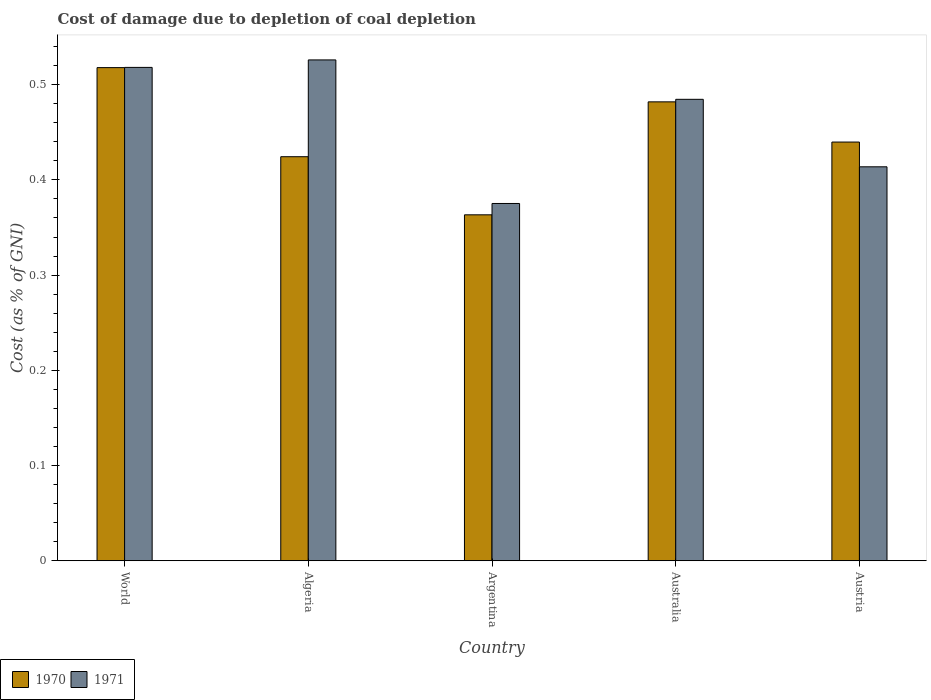How many groups of bars are there?
Ensure brevity in your answer.  5. Are the number of bars on each tick of the X-axis equal?
Provide a short and direct response. Yes. How many bars are there on the 4th tick from the right?
Provide a succinct answer. 2. What is the label of the 5th group of bars from the left?
Keep it short and to the point. Austria. What is the cost of damage caused due to coal depletion in 1971 in Australia?
Provide a short and direct response. 0.48. Across all countries, what is the maximum cost of damage caused due to coal depletion in 1971?
Give a very brief answer. 0.53. Across all countries, what is the minimum cost of damage caused due to coal depletion in 1971?
Offer a very short reply. 0.38. What is the total cost of damage caused due to coal depletion in 1970 in the graph?
Make the answer very short. 2.23. What is the difference between the cost of damage caused due to coal depletion in 1970 in Argentina and that in Australia?
Your response must be concise. -0.12. What is the difference between the cost of damage caused due to coal depletion in 1970 in Argentina and the cost of damage caused due to coal depletion in 1971 in World?
Ensure brevity in your answer.  -0.15. What is the average cost of damage caused due to coal depletion in 1970 per country?
Your answer should be very brief. 0.45. What is the difference between the cost of damage caused due to coal depletion of/in 1970 and cost of damage caused due to coal depletion of/in 1971 in Algeria?
Provide a succinct answer. -0.1. In how many countries, is the cost of damage caused due to coal depletion in 1971 greater than 0.4 %?
Provide a short and direct response. 4. What is the ratio of the cost of damage caused due to coal depletion in 1970 in Argentina to that in Australia?
Your answer should be very brief. 0.75. Is the difference between the cost of damage caused due to coal depletion in 1970 in Algeria and World greater than the difference between the cost of damage caused due to coal depletion in 1971 in Algeria and World?
Offer a terse response. No. What is the difference between the highest and the second highest cost of damage caused due to coal depletion in 1971?
Provide a succinct answer. 0.01. What is the difference between the highest and the lowest cost of damage caused due to coal depletion in 1970?
Make the answer very short. 0.15. In how many countries, is the cost of damage caused due to coal depletion in 1970 greater than the average cost of damage caused due to coal depletion in 1970 taken over all countries?
Provide a short and direct response. 2. What does the 2nd bar from the right in Algeria represents?
Keep it short and to the point. 1970. How many bars are there?
Keep it short and to the point. 10. Are all the bars in the graph horizontal?
Ensure brevity in your answer.  No. How many countries are there in the graph?
Keep it short and to the point. 5. What is the difference between two consecutive major ticks on the Y-axis?
Provide a succinct answer. 0.1. Does the graph contain grids?
Provide a short and direct response. No. Where does the legend appear in the graph?
Make the answer very short. Bottom left. How are the legend labels stacked?
Offer a terse response. Horizontal. What is the title of the graph?
Ensure brevity in your answer.  Cost of damage due to depletion of coal depletion. What is the label or title of the X-axis?
Provide a short and direct response. Country. What is the label or title of the Y-axis?
Provide a short and direct response. Cost (as % of GNI). What is the Cost (as % of GNI) of 1970 in World?
Provide a succinct answer. 0.52. What is the Cost (as % of GNI) of 1971 in World?
Provide a short and direct response. 0.52. What is the Cost (as % of GNI) of 1970 in Algeria?
Provide a succinct answer. 0.42. What is the Cost (as % of GNI) in 1971 in Algeria?
Give a very brief answer. 0.53. What is the Cost (as % of GNI) of 1970 in Argentina?
Offer a terse response. 0.36. What is the Cost (as % of GNI) of 1971 in Argentina?
Ensure brevity in your answer.  0.38. What is the Cost (as % of GNI) in 1970 in Australia?
Offer a very short reply. 0.48. What is the Cost (as % of GNI) in 1971 in Australia?
Provide a short and direct response. 0.48. What is the Cost (as % of GNI) in 1970 in Austria?
Your answer should be very brief. 0.44. What is the Cost (as % of GNI) in 1971 in Austria?
Keep it short and to the point. 0.41. Across all countries, what is the maximum Cost (as % of GNI) in 1970?
Provide a short and direct response. 0.52. Across all countries, what is the maximum Cost (as % of GNI) of 1971?
Your answer should be compact. 0.53. Across all countries, what is the minimum Cost (as % of GNI) of 1970?
Ensure brevity in your answer.  0.36. Across all countries, what is the minimum Cost (as % of GNI) of 1971?
Offer a very short reply. 0.38. What is the total Cost (as % of GNI) of 1970 in the graph?
Your answer should be compact. 2.23. What is the total Cost (as % of GNI) of 1971 in the graph?
Keep it short and to the point. 2.32. What is the difference between the Cost (as % of GNI) in 1970 in World and that in Algeria?
Offer a very short reply. 0.09. What is the difference between the Cost (as % of GNI) in 1971 in World and that in Algeria?
Provide a short and direct response. -0.01. What is the difference between the Cost (as % of GNI) of 1970 in World and that in Argentina?
Provide a short and direct response. 0.15. What is the difference between the Cost (as % of GNI) of 1971 in World and that in Argentina?
Give a very brief answer. 0.14. What is the difference between the Cost (as % of GNI) of 1970 in World and that in Australia?
Offer a terse response. 0.04. What is the difference between the Cost (as % of GNI) of 1971 in World and that in Australia?
Provide a succinct answer. 0.03. What is the difference between the Cost (as % of GNI) in 1970 in World and that in Austria?
Your response must be concise. 0.08. What is the difference between the Cost (as % of GNI) of 1971 in World and that in Austria?
Give a very brief answer. 0.1. What is the difference between the Cost (as % of GNI) of 1970 in Algeria and that in Argentina?
Your answer should be compact. 0.06. What is the difference between the Cost (as % of GNI) in 1971 in Algeria and that in Argentina?
Give a very brief answer. 0.15. What is the difference between the Cost (as % of GNI) of 1970 in Algeria and that in Australia?
Provide a succinct answer. -0.06. What is the difference between the Cost (as % of GNI) in 1971 in Algeria and that in Australia?
Your answer should be compact. 0.04. What is the difference between the Cost (as % of GNI) in 1970 in Algeria and that in Austria?
Give a very brief answer. -0.02. What is the difference between the Cost (as % of GNI) in 1971 in Algeria and that in Austria?
Provide a short and direct response. 0.11. What is the difference between the Cost (as % of GNI) of 1970 in Argentina and that in Australia?
Keep it short and to the point. -0.12. What is the difference between the Cost (as % of GNI) in 1971 in Argentina and that in Australia?
Give a very brief answer. -0.11. What is the difference between the Cost (as % of GNI) in 1970 in Argentina and that in Austria?
Your response must be concise. -0.08. What is the difference between the Cost (as % of GNI) in 1971 in Argentina and that in Austria?
Your answer should be very brief. -0.04. What is the difference between the Cost (as % of GNI) of 1970 in Australia and that in Austria?
Provide a short and direct response. 0.04. What is the difference between the Cost (as % of GNI) of 1971 in Australia and that in Austria?
Your answer should be compact. 0.07. What is the difference between the Cost (as % of GNI) of 1970 in World and the Cost (as % of GNI) of 1971 in Algeria?
Provide a short and direct response. -0.01. What is the difference between the Cost (as % of GNI) of 1970 in World and the Cost (as % of GNI) of 1971 in Argentina?
Make the answer very short. 0.14. What is the difference between the Cost (as % of GNI) of 1970 in World and the Cost (as % of GNI) of 1971 in Austria?
Your answer should be compact. 0.1. What is the difference between the Cost (as % of GNI) in 1970 in Algeria and the Cost (as % of GNI) in 1971 in Argentina?
Offer a terse response. 0.05. What is the difference between the Cost (as % of GNI) of 1970 in Algeria and the Cost (as % of GNI) of 1971 in Australia?
Provide a short and direct response. -0.06. What is the difference between the Cost (as % of GNI) of 1970 in Algeria and the Cost (as % of GNI) of 1971 in Austria?
Your answer should be compact. 0.01. What is the difference between the Cost (as % of GNI) in 1970 in Argentina and the Cost (as % of GNI) in 1971 in Australia?
Offer a very short reply. -0.12. What is the difference between the Cost (as % of GNI) in 1970 in Argentina and the Cost (as % of GNI) in 1971 in Austria?
Your answer should be compact. -0.05. What is the difference between the Cost (as % of GNI) in 1970 in Australia and the Cost (as % of GNI) in 1971 in Austria?
Your response must be concise. 0.07. What is the average Cost (as % of GNI) of 1970 per country?
Your answer should be very brief. 0.45. What is the average Cost (as % of GNI) in 1971 per country?
Give a very brief answer. 0.46. What is the difference between the Cost (as % of GNI) in 1970 and Cost (as % of GNI) in 1971 in World?
Keep it short and to the point. -0. What is the difference between the Cost (as % of GNI) of 1970 and Cost (as % of GNI) of 1971 in Algeria?
Make the answer very short. -0.1. What is the difference between the Cost (as % of GNI) in 1970 and Cost (as % of GNI) in 1971 in Argentina?
Offer a terse response. -0.01. What is the difference between the Cost (as % of GNI) in 1970 and Cost (as % of GNI) in 1971 in Australia?
Your response must be concise. -0. What is the difference between the Cost (as % of GNI) of 1970 and Cost (as % of GNI) of 1971 in Austria?
Keep it short and to the point. 0.03. What is the ratio of the Cost (as % of GNI) of 1970 in World to that in Algeria?
Your answer should be very brief. 1.22. What is the ratio of the Cost (as % of GNI) in 1971 in World to that in Algeria?
Provide a succinct answer. 0.99. What is the ratio of the Cost (as % of GNI) of 1970 in World to that in Argentina?
Provide a succinct answer. 1.43. What is the ratio of the Cost (as % of GNI) in 1971 in World to that in Argentina?
Your answer should be very brief. 1.38. What is the ratio of the Cost (as % of GNI) of 1970 in World to that in Australia?
Your answer should be very brief. 1.07. What is the ratio of the Cost (as % of GNI) in 1971 in World to that in Australia?
Your response must be concise. 1.07. What is the ratio of the Cost (as % of GNI) of 1970 in World to that in Austria?
Your response must be concise. 1.18. What is the ratio of the Cost (as % of GNI) of 1971 in World to that in Austria?
Your response must be concise. 1.25. What is the ratio of the Cost (as % of GNI) in 1970 in Algeria to that in Argentina?
Provide a short and direct response. 1.17. What is the ratio of the Cost (as % of GNI) in 1971 in Algeria to that in Argentina?
Offer a very short reply. 1.4. What is the ratio of the Cost (as % of GNI) in 1970 in Algeria to that in Australia?
Offer a very short reply. 0.88. What is the ratio of the Cost (as % of GNI) of 1971 in Algeria to that in Australia?
Provide a short and direct response. 1.09. What is the ratio of the Cost (as % of GNI) of 1971 in Algeria to that in Austria?
Your answer should be very brief. 1.27. What is the ratio of the Cost (as % of GNI) in 1970 in Argentina to that in Australia?
Make the answer very short. 0.75. What is the ratio of the Cost (as % of GNI) in 1971 in Argentina to that in Australia?
Keep it short and to the point. 0.77. What is the ratio of the Cost (as % of GNI) in 1970 in Argentina to that in Austria?
Ensure brevity in your answer.  0.83. What is the ratio of the Cost (as % of GNI) in 1971 in Argentina to that in Austria?
Ensure brevity in your answer.  0.91. What is the ratio of the Cost (as % of GNI) in 1970 in Australia to that in Austria?
Your answer should be compact. 1.1. What is the ratio of the Cost (as % of GNI) in 1971 in Australia to that in Austria?
Make the answer very short. 1.17. What is the difference between the highest and the second highest Cost (as % of GNI) in 1970?
Provide a short and direct response. 0.04. What is the difference between the highest and the second highest Cost (as % of GNI) of 1971?
Your answer should be compact. 0.01. What is the difference between the highest and the lowest Cost (as % of GNI) of 1970?
Provide a short and direct response. 0.15. What is the difference between the highest and the lowest Cost (as % of GNI) of 1971?
Your answer should be compact. 0.15. 